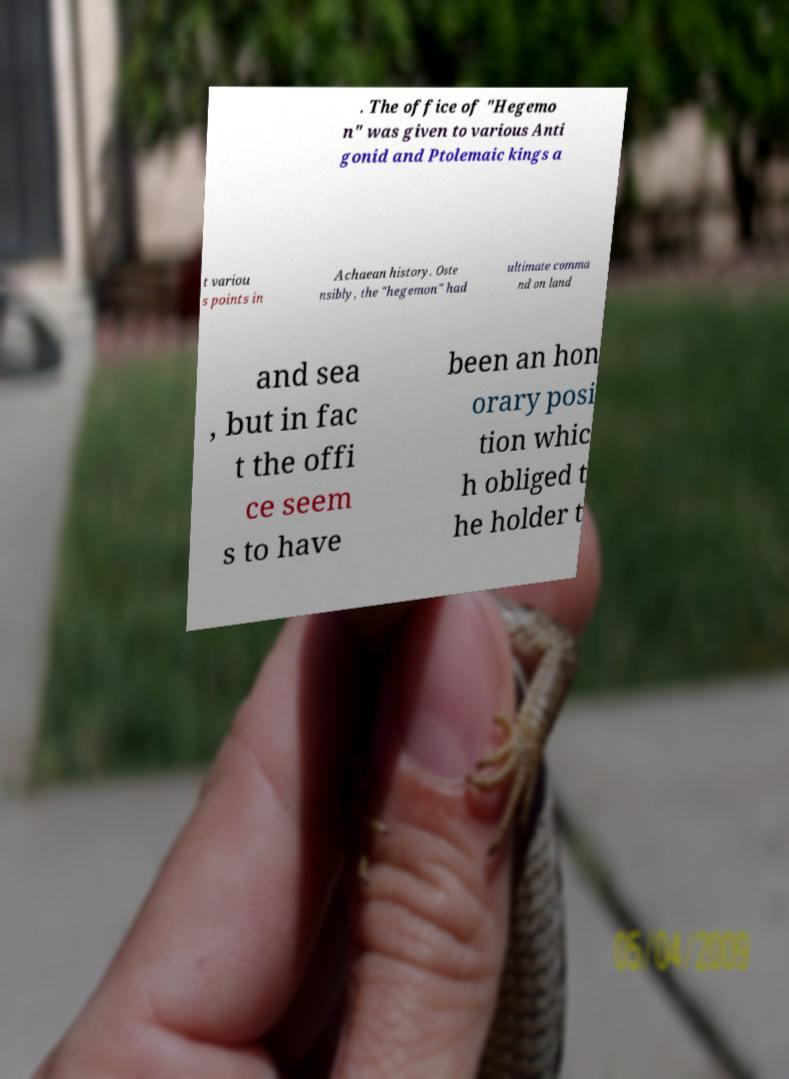What messages or text are displayed in this image? I need them in a readable, typed format. . The office of "Hegemo n" was given to various Anti gonid and Ptolemaic kings a t variou s points in Achaean history. Oste nsibly, the "hegemon" had ultimate comma nd on land and sea , but in fac t the offi ce seem s to have been an hon orary posi tion whic h obliged t he holder t 